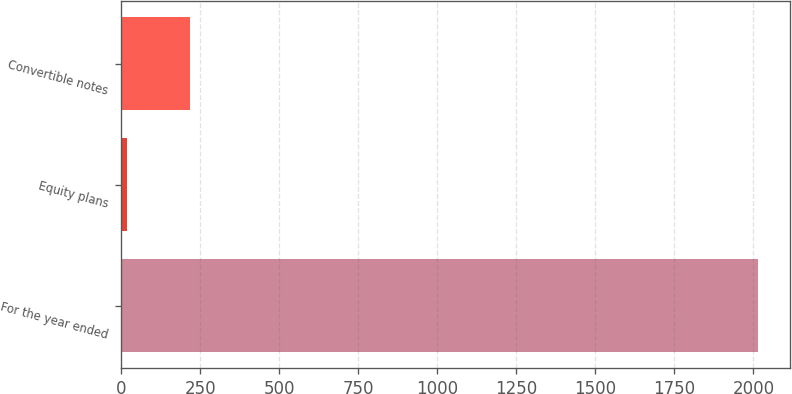Convert chart. <chart><loc_0><loc_0><loc_500><loc_500><bar_chart><fcel>For the year ended<fcel>Equity plans<fcel>Convertible notes<nl><fcel>2015<fcel>18<fcel>217.7<nl></chart> 